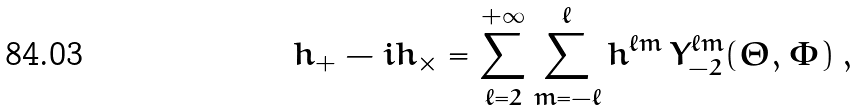Convert formula to latex. <formula><loc_0><loc_0><loc_500><loc_500>h _ { + } - i h _ { \times } = \sum ^ { + \infty } _ { \ell = 2 } \sum ^ { \ell } _ { m = - \ell } h ^ { \ell m } \, Y ^ { \ell m } _ { - 2 } ( \Theta , \Phi ) \, ,</formula> 